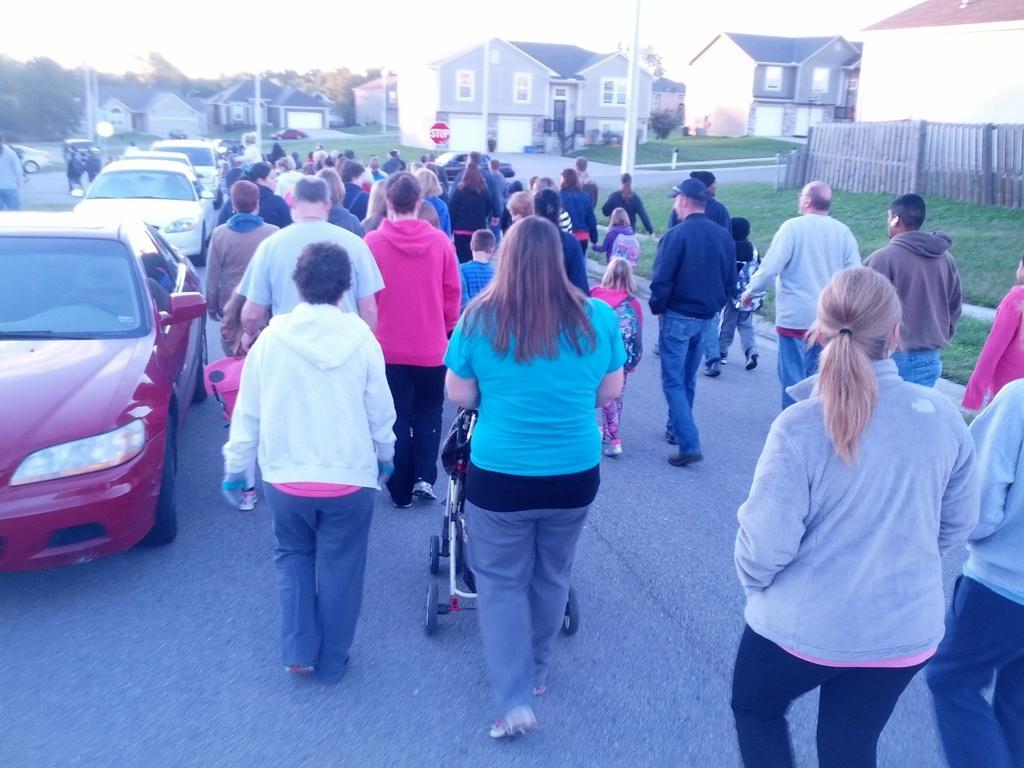How would you summarize this image in a sentence or two? In the image there are a lot of people walking on the road and on the left side there are vehicles, around the road there are houses and trees. 